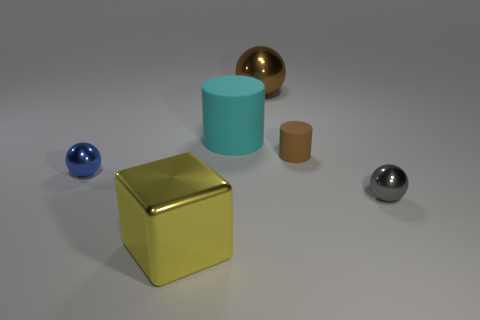What number of cubes are either small metal objects or rubber objects?
Offer a terse response. 0. Does the large ball have the same color as the metallic cube?
Your answer should be compact. No. Is the number of cylinders in front of the small gray ball the same as the number of large rubber things in front of the large cylinder?
Offer a terse response. Yes. The tiny cylinder has what color?
Make the answer very short. Brown. How many things are balls behind the brown cylinder or large things?
Give a very brief answer. 3. Do the sphere behind the large cyan cylinder and the metallic thing in front of the small gray sphere have the same size?
Provide a short and direct response. Yes. Are there any other things that are made of the same material as the large yellow cube?
Offer a terse response. Yes. What number of objects are either spheres to the right of the big rubber cylinder or shiny objects right of the tiny blue metal sphere?
Provide a succinct answer. 3. Is the blue thing made of the same material as the tiny object in front of the blue thing?
Provide a succinct answer. Yes. What is the shape of the shiny thing that is both behind the tiny gray thing and to the left of the big cylinder?
Provide a short and direct response. Sphere. 